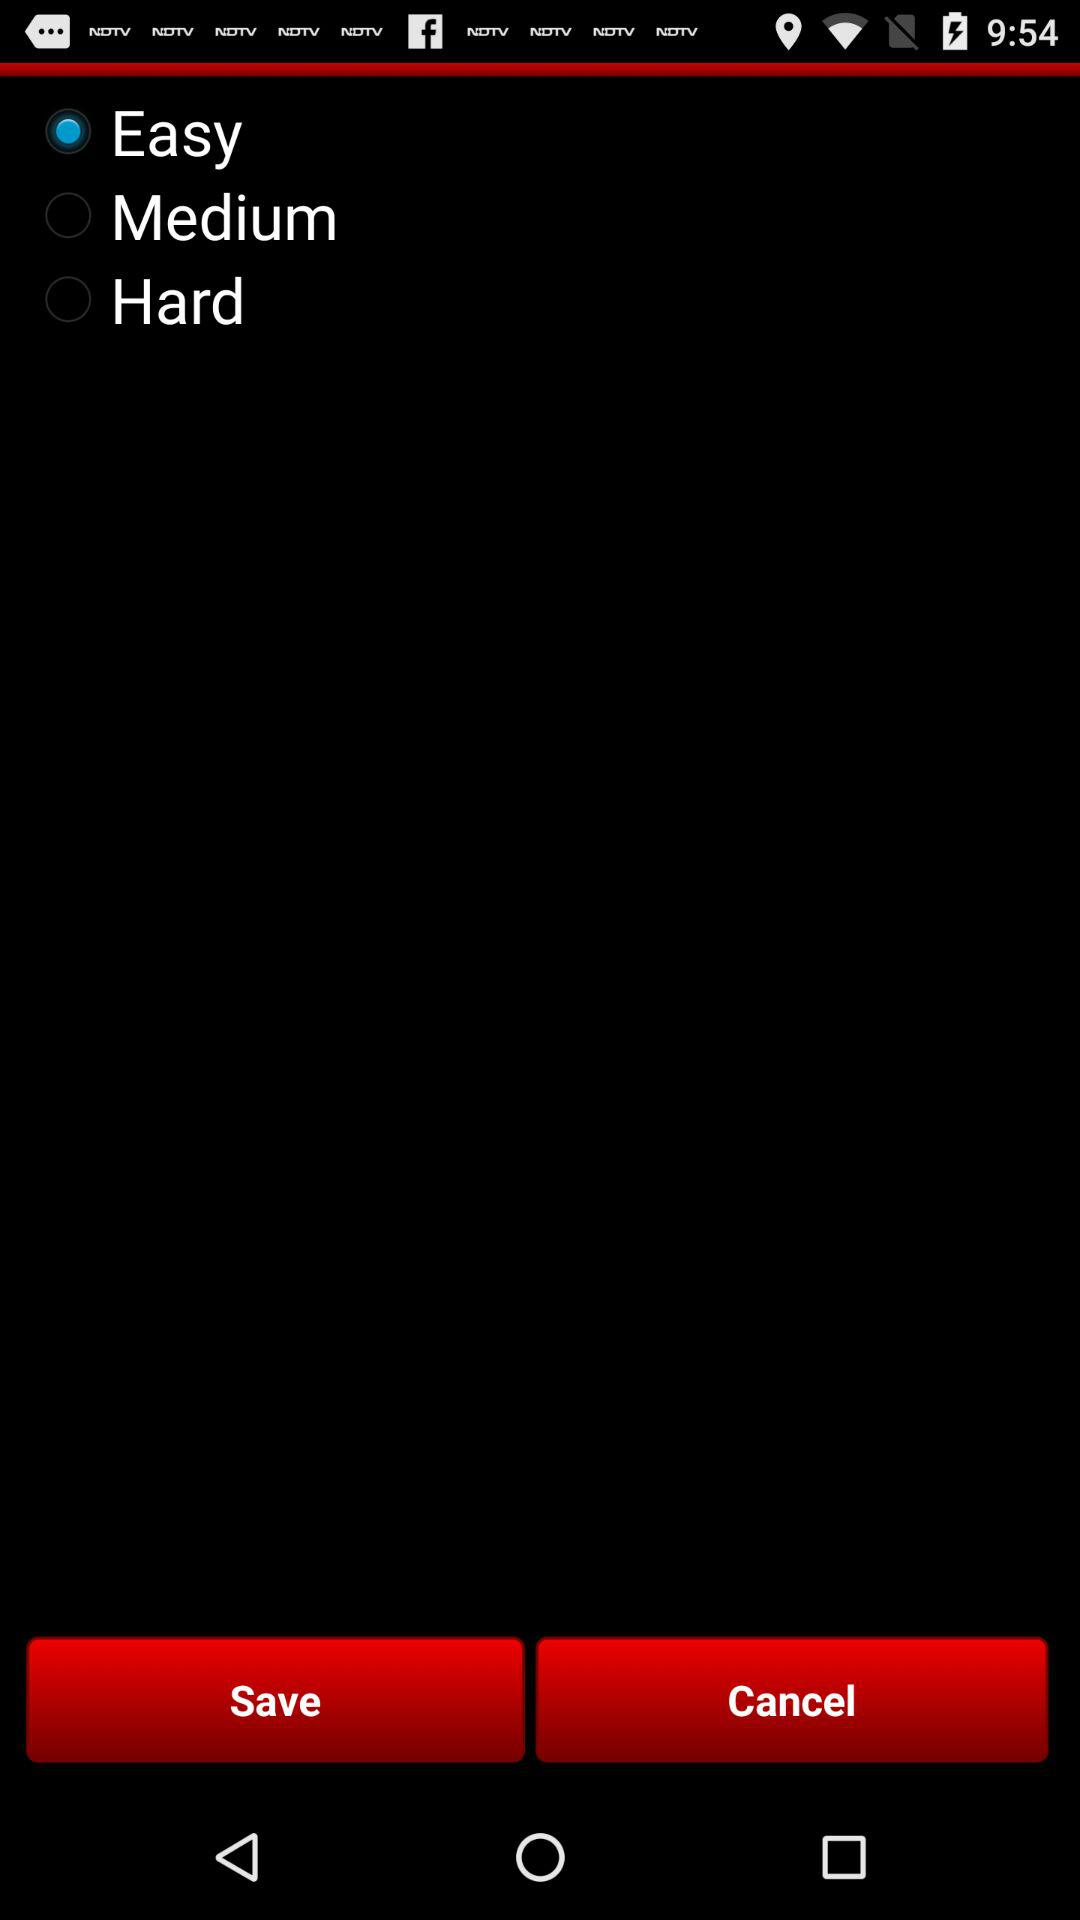Which option is selected? The selected option is "Easy". 